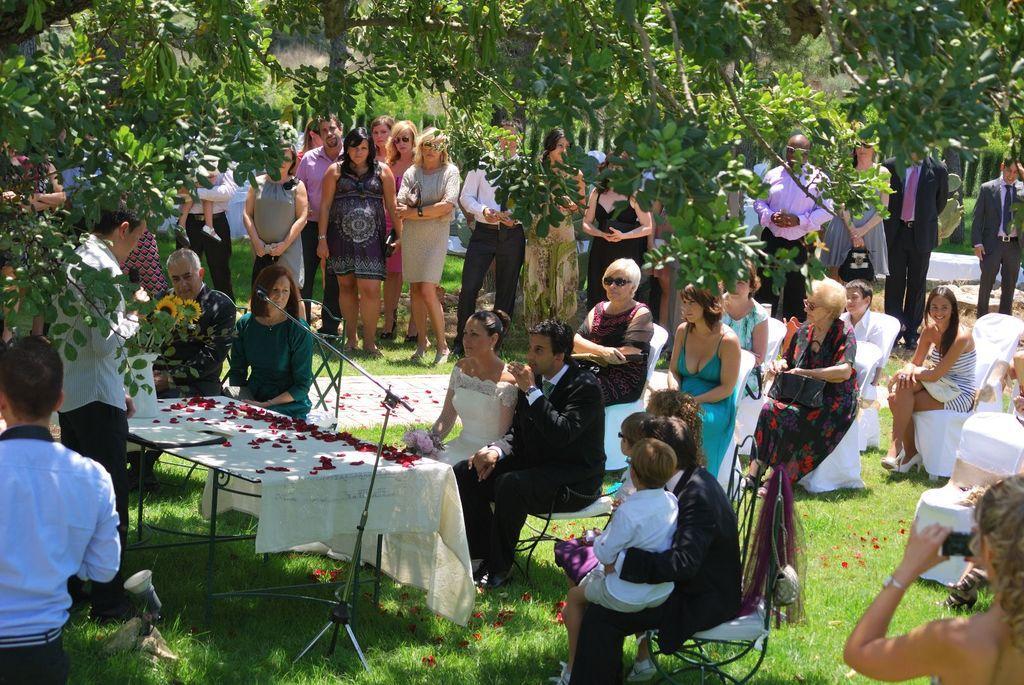Please provide a concise description of this image. The image is taken in the ground in which some people are sitting in the chairs which are on the ground while the other people are standing beside them. There is a table in front of them on which there are rose flower leaves and a mic and the sunflowers on it. Behind the man who is standing in front of table there is a big tree. 